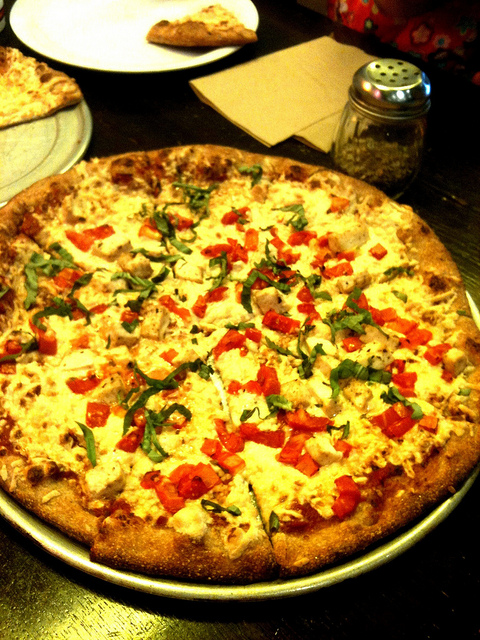<image>What is the table made of? I am not sure what material the table is made of. The possibilities could be formica, stone, wood or plastic. What is the table made of? I am not sure what the table is made of. It can be made of formica, stone, wood, or plastic. 